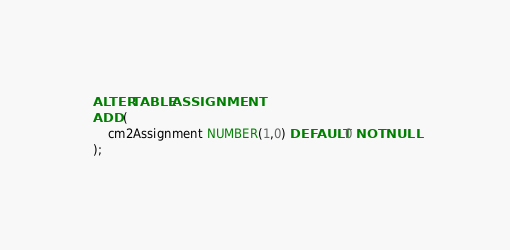Convert code to text. <code><loc_0><loc_0><loc_500><loc_500><_SQL_>ALTER TABLE ASSIGNMENT
ADD (
	cm2Assignment NUMBER(1,0) DEFAULT 0 NOT NULL
);</code> 